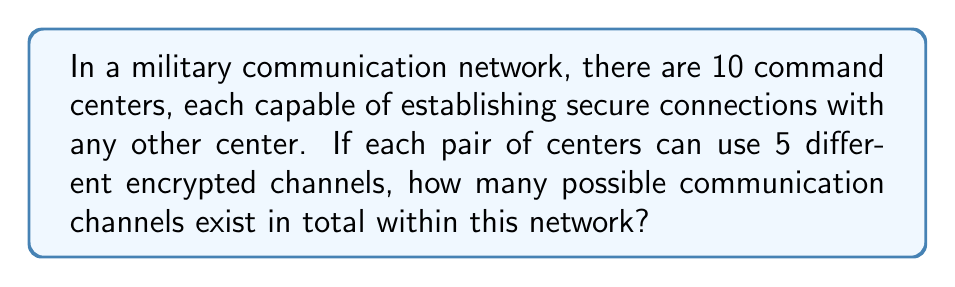Solve this math problem. Let's approach this step-by-step:

1) First, we need to determine how many pairs of command centers can be formed. This is a combination problem, as the order doesn't matter (A communicating with B is the same as B communicating with A).

2) The number of ways to choose 2 centers from 10 is given by the combination formula:

   $$\binom{10}{2} = \frac{10!}{2!(10-2)!} = \frac{10 \cdot 9}{2 \cdot 1} = 45$$

3) Now, for each of these 45 pairs, there are 5 possible encrypted channels.

4) To find the total number of possible communication channels, we multiply the number of pairs by the number of channels per pair:

   $$45 \cdot 5 = 225$$

This calculation gives us the total number of possible communication channels in the network.
Answer: 225 channels 